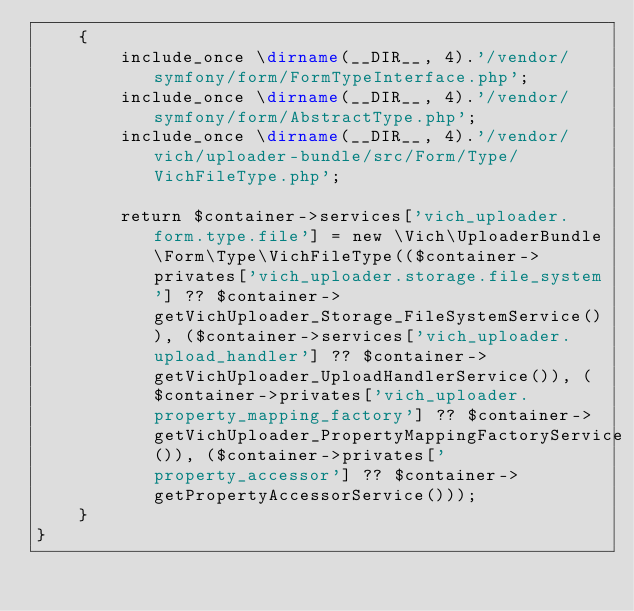<code> <loc_0><loc_0><loc_500><loc_500><_PHP_>    {
        include_once \dirname(__DIR__, 4).'/vendor/symfony/form/FormTypeInterface.php';
        include_once \dirname(__DIR__, 4).'/vendor/symfony/form/AbstractType.php';
        include_once \dirname(__DIR__, 4).'/vendor/vich/uploader-bundle/src/Form/Type/VichFileType.php';

        return $container->services['vich_uploader.form.type.file'] = new \Vich\UploaderBundle\Form\Type\VichFileType(($container->privates['vich_uploader.storage.file_system'] ?? $container->getVichUploader_Storage_FileSystemService()), ($container->services['vich_uploader.upload_handler'] ?? $container->getVichUploader_UploadHandlerService()), ($container->privates['vich_uploader.property_mapping_factory'] ?? $container->getVichUploader_PropertyMappingFactoryService()), ($container->privates['property_accessor'] ?? $container->getPropertyAccessorService()));
    }
}
</code> 